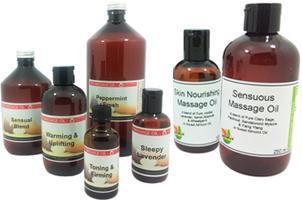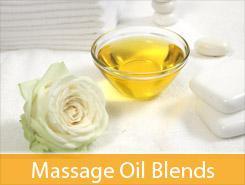The first image is the image on the left, the second image is the image on the right. Examine the images to the left and right. Is the description "There is a candle in one image." accurate? Answer yes or no. No. 